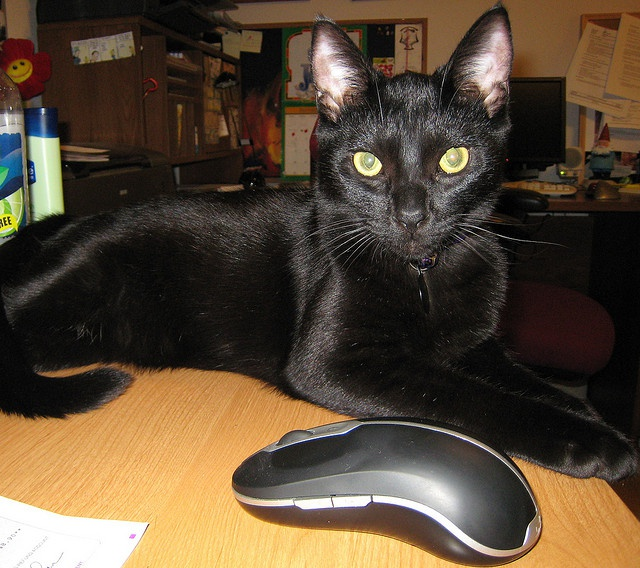Describe the objects in this image and their specific colors. I can see cat in black and gray tones, mouse in black, gray, darkgray, and white tones, chair in black, gray, and maroon tones, tv in black, maroon, and gray tones, and bottle in black, blue, maroon, and gray tones in this image. 